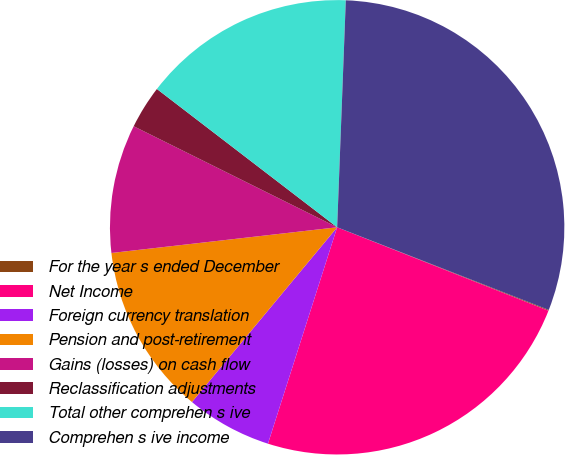Convert chart to OTSL. <chart><loc_0><loc_0><loc_500><loc_500><pie_chart><fcel>For the year s ended December<fcel>Net Income<fcel>Foreign currency translation<fcel>Pension and post-retirement<fcel>Gains (losses) on cash flow<fcel>Reclassification adjustments<fcel>Total other comprehen s ive<fcel>Comprehen s ive income<nl><fcel>0.06%<fcel>23.94%<fcel>6.11%<fcel>12.16%<fcel>9.14%<fcel>3.08%<fcel>15.19%<fcel>30.32%<nl></chart> 